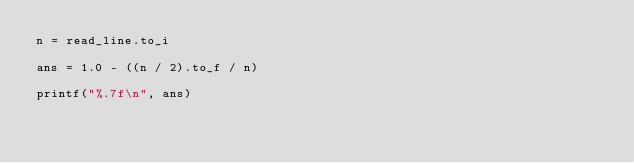Convert code to text. <code><loc_0><loc_0><loc_500><loc_500><_Crystal_>n = read_line.to_i

ans = 1.0 - ((n / 2).to_f / n)

printf("%.7f\n", ans)</code> 